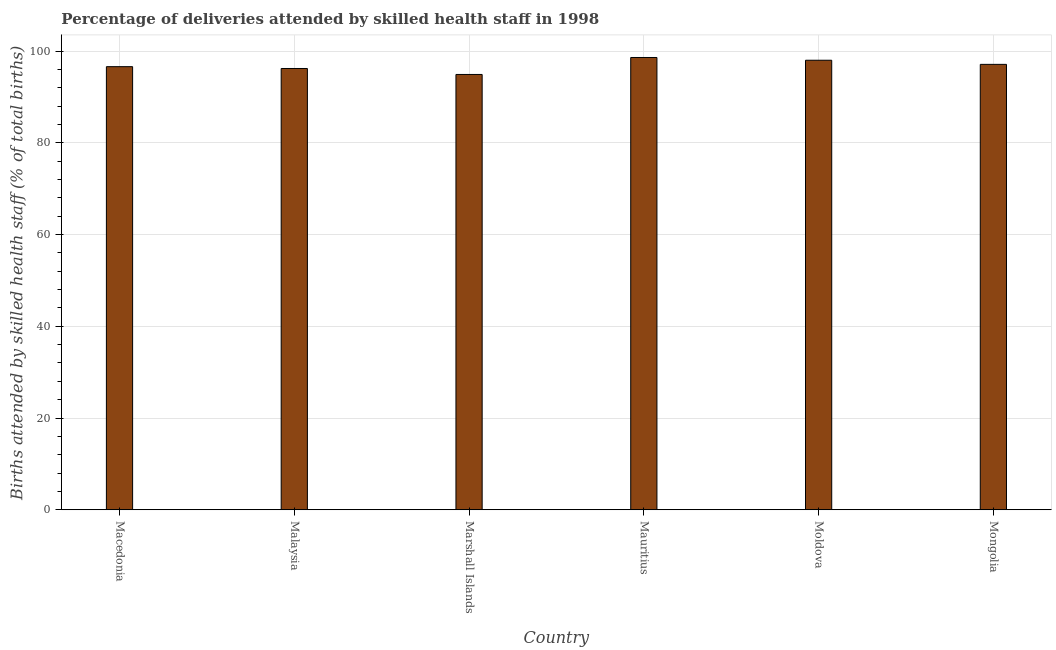What is the title of the graph?
Keep it short and to the point. Percentage of deliveries attended by skilled health staff in 1998. What is the label or title of the Y-axis?
Keep it short and to the point. Births attended by skilled health staff (% of total births). Across all countries, what is the maximum number of births attended by skilled health staff?
Give a very brief answer. 98.6. Across all countries, what is the minimum number of births attended by skilled health staff?
Your response must be concise. 94.9. In which country was the number of births attended by skilled health staff maximum?
Ensure brevity in your answer.  Mauritius. In which country was the number of births attended by skilled health staff minimum?
Provide a succinct answer. Marshall Islands. What is the sum of the number of births attended by skilled health staff?
Offer a terse response. 581.4. What is the average number of births attended by skilled health staff per country?
Provide a short and direct response. 96.9. What is the median number of births attended by skilled health staff?
Ensure brevity in your answer.  96.85. In how many countries, is the number of births attended by skilled health staff greater than 76 %?
Provide a succinct answer. 6. Is the number of births attended by skilled health staff in Macedonia less than that in Mauritius?
Offer a very short reply. Yes. What is the difference between the highest and the second highest number of births attended by skilled health staff?
Your answer should be very brief. 0.6. What is the difference between the highest and the lowest number of births attended by skilled health staff?
Your answer should be compact. 3.7. In how many countries, is the number of births attended by skilled health staff greater than the average number of births attended by skilled health staff taken over all countries?
Offer a very short reply. 3. How many bars are there?
Make the answer very short. 6. Are all the bars in the graph horizontal?
Provide a succinct answer. No. How many countries are there in the graph?
Make the answer very short. 6. What is the difference between two consecutive major ticks on the Y-axis?
Offer a very short reply. 20. What is the Births attended by skilled health staff (% of total births) in Macedonia?
Your response must be concise. 96.6. What is the Births attended by skilled health staff (% of total births) in Malaysia?
Offer a very short reply. 96.2. What is the Births attended by skilled health staff (% of total births) of Marshall Islands?
Make the answer very short. 94.9. What is the Births attended by skilled health staff (% of total births) of Mauritius?
Your response must be concise. 98.6. What is the Births attended by skilled health staff (% of total births) of Mongolia?
Keep it short and to the point. 97.1. What is the difference between the Births attended by skilled health staff (% of total births) in Macedonia and Moldova?
Your response must be concise. -1.4. What is the difference between the Births attended by skilled health staff (% of total births) in Macedonia and Mongolia?
Your response must be concise. -0.5. What is the difference between the Births attended by skilled health staff (% of total births) in Malaysia and Marshall Islands?
Your answer should be very brief. 1.3. What is the difference between the Births attended by skilled health staff (% of total births) in Malaysia and Moldova?
Your response must be concise. -1.8. What is the difference between the Births attended by skilled health staff (% of total births) in Malaysia and Mongolia?
Give a very brief answer. -0.9. What is the difference between the Births attended by skilled health staff (% of total births) in Marshall Islands and Mauritius?
Offer a very short reply. -3.7. What is the difference between the Births attended by skilled health staff (% of total births) in Marshall Islands and Moldova?
Make the answer very short. -3.1. What is the difference between the Births attended by skilled health staff (% of total births) in Mauritius and Moldova?
Keep it short and to the point. 0.6. What is the difference between the Births attended by skilled health staff (% of total births) in Mauritius and Mongolia?
Your response must be concise. 1.5. What is the ratio of the Births attended by skilled health staff (% of total births) in Macedonia to that in Malaysia?
Offer a terse response. 1. What is the ratio of the Births attended by skilled health staff (% of total births) in Macedonia to that in Marshall Islands?
Make the answer very short. 1.02. What is the ratio of the Births attended by skilled health staff (% of total births) in Macedonia to that in Mauritius?
Ensure brevity in your answer.  0.98. What is the ratio of the Births attended by skilled health staff (% of total births) in Malaysia to that in Marshall Islands?
Give a very brief answer. 1.01. What is the ratio of the Births attended by skilled health staff (% of total births) in Malaysia to that in Moldova?
Provide a short and direct response. 0.98. What is the ratio of the Births attended by skilled health staff (% of total births) in Malaysia to that in Mongolia?
Ensure brevity in your answer.  0.99. What is the ratio of the Births attended by skilled health staff (% of total births) in Marshall Islands to that in Mauritius?
Give a very brief answer. 0.96. What is the ratio of the Births attended by skilled health staff (% of total births) in Marshall Islands to that in Mongolia?
Give a very brief answer. 0.98. What is the ratio of the Births attended by skilled health staff (% of total births) in Moldova to that in Mongolia?
Give a very brief answer. 1.01. 